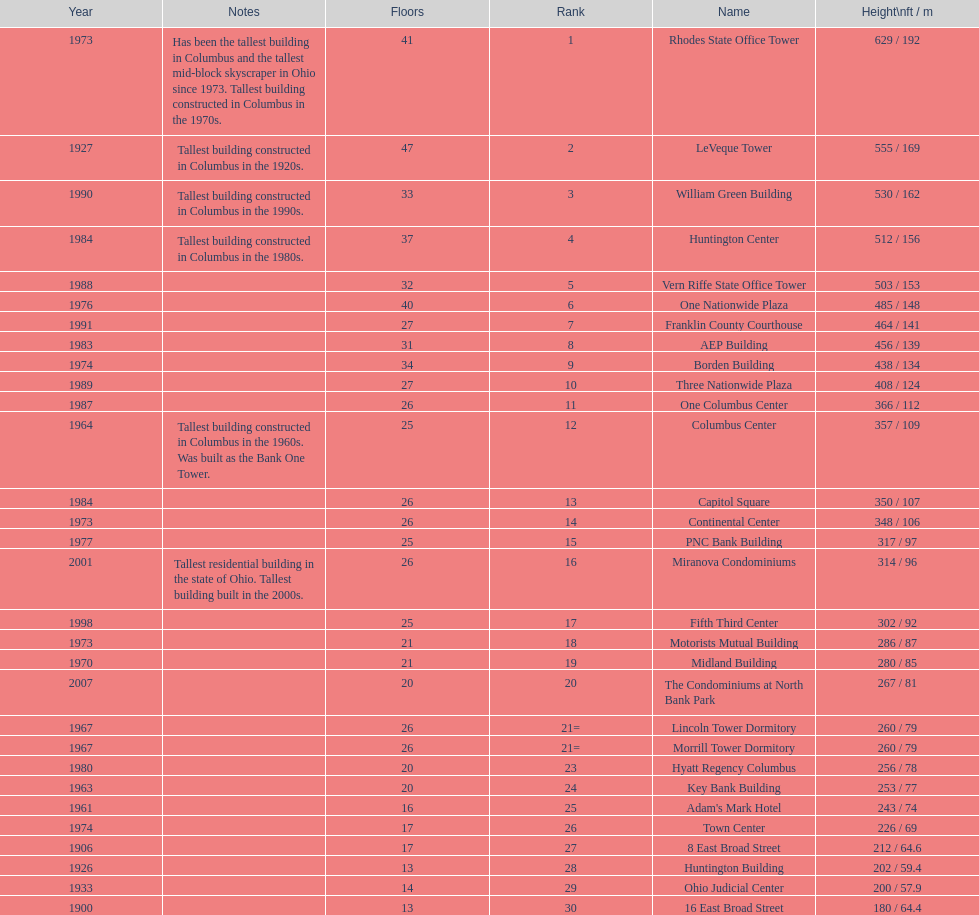What is the number of buildings under 200 ft? 1. 